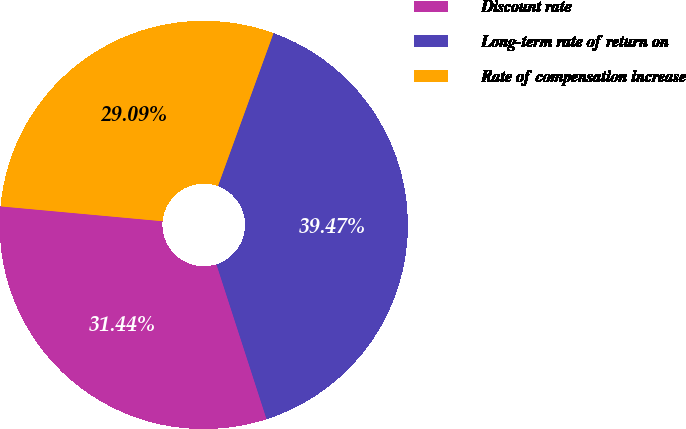<chart> <loc_0><loc_0><loc_500><loc_500><pie_chart><fcel>Discount rate<fcel>Long-term rate of return on<fcel>Rate of compensation increase<nl><fcel>31.44%<fcel>39.47%<fcel>29.09%<nl></chart> 